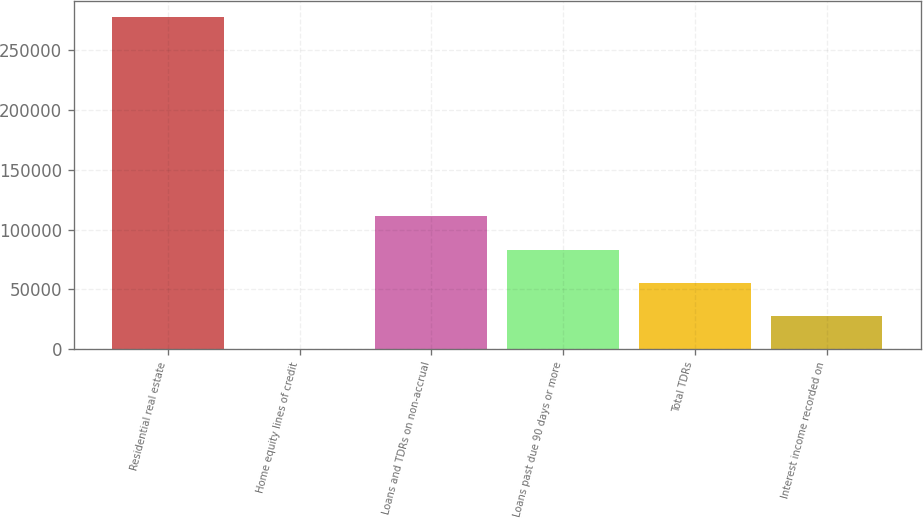<chart> <loc_0><loc_0><loc_500><loc_500><bar_chart><fcel>Residential real estate<fcel>Home equity lines of credit<fcel>Loans and TDRs on non-accrual<fcel>Loans past due 90 days or more<fcel>Total TDRs<fcel>Interest income recorded on<nl><fcel>277253<fcel>170<fcel>111003<fcel>83294.9<fcel>55586.6<fcel>27878.3<nl></chart> 